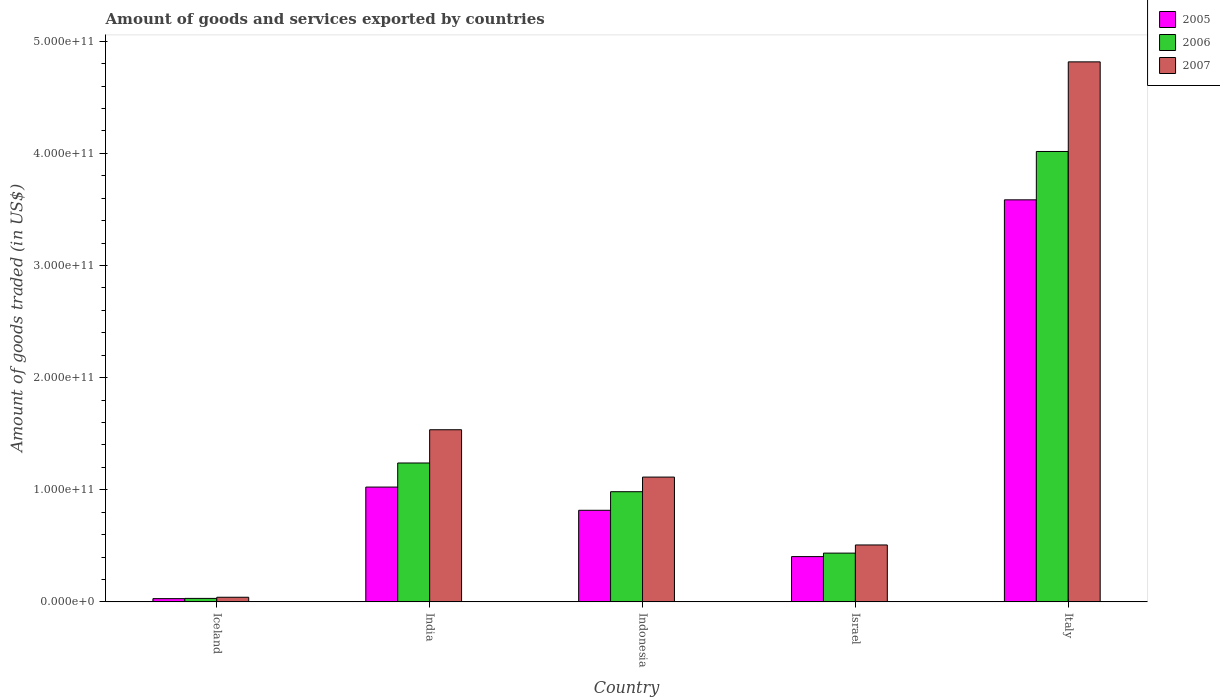How many different coloured bars are there?
Your answer should be very brief. 3. How many groups of bars are there?
Give a very brief answer. 5. Are the number of bars per tick equal to the number of legend labels?
Provide a succinct answer. Yes. Are the number of bars on each tick of the X-axis equal?
Make the answer very short. Yes. How many bars are there on the 3rd tick from the right?
Your answer should be compact. 3. What is the label of the 5th group of bars from the left?
Keep it short and to the point. Italy. In how many cases, is the number of bars for a given country not equal to the number of legend labels?
Keep it short and to the point. 0. What is the total amount of goods and services exported in 2007 in India?
Offer a very short reply. 1.54e+11. Across all countries, what is the maximum total amount of goods and services exported in 2005?
Provide a short and direct response. 3.59e+11. Across all countries, what is the minimum total amount of goods and services exported in 2006?
Make the answer very short. 3.10e+09. In which country was the total amount of goods and services exported in 2006 maximum?
Ensure brevity in your answer.  Italy. In which country was the total amount of goods and services exported in 2007 minimum?
Your answer should be compact. Iceland. What is the total total amount of goods and services exported in 2007 in the graph?
Offer a terse response. 8.01e+11. What is the difference between the total amount of goods and services exported in 2007 in India and that in Italy?
Ensure brevity in your answer.  -3.28e+11. What is the difference between the total amount of goods and services exported in 2006 in India and the total amount of goods and services exported in 2007 in Indonesia?
Offer a very short reply. 1.26e+1. What is the average total amount of goods and services exported in 2007 per country?
Your response must be concise. 1.60e+11. What is the difference between the total amount of goods and services exported of/in 2005 and total amount of goods and services exported of/in 2006 in Italy?
Provide a short and direct response. -4.31e+1. What is the ratio of the total amount of goods and services exported in 2006 in Iceland to that in Indonesia?
Provide a succinct answer. 0.03. Is the total amount of goods and services exported in 2005 in Iceland less than that in Israel?
Offer a terse response. Yes. What is the difference between the highest and the second highest total amount of goods and services exported in 2006?
Offer a very short reply. 2.78e+11. What is the difference between the highest and the lowest total amount of goods and services exported in 2006?
Give a very brief answer. 3.99e+11. In how many countries, is the total amount of goods and services exported in 2006 greater than the average total amount of goods and services exported in 2006 taken over all countries?
Make the answer very short. 1. Is the sum of the total amount of goods and services exported in 2005 in India and Israel greater than the maximum total amount of goods and services exported in 2007 across all countries?
Ensure brevity in your answer.  No. Is it the case that in every country, the sum of the total amount of goods and services exported in 2005 and total amount of goods and services exported in 2006 is greater than the total amount of goods and services exported in 2007?
Provide a succinct answer. Yes. How many bars are there?
Provide a short and direct response. 15. Are all the bars in the graph horizontal?
Provide a succinct answer. No. How many countries are there in the graph?
Ensure brevity in your answer.  5. What is the difference between two consecutive major ticks on the Y-axis?
Make the answer very short. 1.00e+11. Are the values on the major ticks of Y-axis written in scientific E-notation?
Offer a very short reply. Yes. How are the legend labels stacked?
Make the answer very short. Vertical. What is the title of the graph?
Provide a short and direct response. Amount of goods and services exported by countries. Does "2008" appear as one of the legend labels in the graph?
Ensure brevity in your answer.  No. What is the label or title of the Y-axis?
Give a very brief answer. Amount of goods traded (in US$). What is the Amount of goods traded (in US$) of 2005 in Iceland?
Your response must be concise. 2.89e+09. What is the Amount of goods traded (in US$) in 2006 in Iceland?
Your answer should be very brief. 3.10e+09. What is the Amount of goods traded (in US$) of 2007 in Iceland?
Ensure brevity in your answer.  4.12e+09. What is the Amount of goods traded (in US$) of 2005 in India?
Your answer should be very brief. 1.02e+11. What is the Amount of goods traded (in US$) in 2006 in India?
Give a very brief answer. 1.24e+11. What is the Amount of goods traded (in US$) in 2007 in India?
Make the answer very short. 1.54e+11. What is the Amount of goods traded (in US$) in 2005 in Indonesia?
Offer a very short reply. 8.17e+1. What is the Amount of goods traded (in US$) of 2006 in Indonesia?
Your response must be concise. 9.83e+1. What is the Amount of goods traded (in US$) in 2007 in Indonesia?
Offer a terse response. 1.11e+11. What is the Amount of goods traded (in US$) of 2005 in Israel?
Your response must be concise. 4.04e+1. What is the Amount of goods traded (in US$) of 2006 in Israel?
Offer a terse response. 4.35e+1. What is the Amount of goods traded (in US$) of 2007 in Israel?
Your response must be concise. 5.08e+1. What is the Amount of goods traded (in US$) of 2005 in Italy?
Provide a short and direct response. 3.59e+11. What is the Amount of goods traded (in US$) in 2006 in Italy?
Offer a terse response. 4.02e+11. What is the Amount of goods traded (in US$) of 2007 in Italy?
Ensure brevity in your answer.  4.82e+11. Across all countries, what is the maximum Amount of goods traded (in US$) of 2005?
Provide a succinct answer. 3.59e+11. Across all countries, what is the maximum Amount of goods traded (in US$) in 2006?
Make the answer very short. 4.02e+11. Across all countries, what is the maximum Amount of goods traded (in US$) in 2007?
Your answer should be compact. 4.82e+11. Across all countries, what is the minimum Amount of goods traded (in US$) of 2005?
Ensure brevity in your answer.  2.89e+09. Across all countries, what is the minimum Amount of goods traded (in US$) in 2006?
Your response must be concise. 3.10e+09. Across all countries, what is the minimum Amount of goods traded (in US$) of 2007?
Keep it short and to the point. 4.12e+09. What is the total Amount of goods traded (in US$) of 2005 in the graph?
Your answer should be compact. 5.86e+11. What is the total Amount of goods traded (in US$) in 2006 in the graph?
Keep it short and to the point. 6.70e+11. What is the total Amount of goods traded (in US$) in 2007 in the graph?
Give a very brief answer. 8.01e+11. What is the difference between the Amount of goods traded (in US$) in 2005 in Iceland and that in India?
Your answer should be very brief. -9.95e+1. What is the difference between the Amount of goods traded (in US$) in 2006 in Iceland and that in India?
Provide a succinct answer. -1.21e+11. What is the difference between the Amount of goods traded (in US$) in 2007 in Iceland and that in India?
Offer a terse response. -1.49e+11. What is the difference between the Amount of goods traded (in US$) in 2005 in Iceland and that in Indonesia?
Offer a terse response. -7.88e+1. What is the difference between the Amount of goods traded (in US$) in 2006 in Iceland and that in Indonesia?
Your response must be concise. -9.52e+1. What is the difference between the Amount of goods traded (in US$) in 2007 in Iceland and that in Indonesia?
Keep it short and to the point. -1.07e+11. What is the difference between the Amount of goods traded (in US$) in 2005 in Iceland and that in Israel?
Your answer should be compact. -3.75e+1. What is the difference between the Amount of goods traded (in US$) of 2006 in Iceland and that in Israel?
Provide a short and direct response. -4.04e+1. What is the difference between the Amount of goods traded (in US$) of 2007 in Iceland and that in Israel?
Your response must be concise. -4.66e+1. What is the difference between the Amount of goods traded (in US$) in 2005 in Iceland and that in Italy?
Your answer should be very brief. -3.56e+11. What is the difference between the Amount of goods traded (in US$) in 2006 in Iceland and that in Italy?
Ensure brevity in your answer.  -3.99e+11. What is the difference between the Amount of goods traded (in US$) of 2007 in Iceland and that in Italy?
Your answer should be very brief. -4.78e+11. What is the difference between the Amount of goods traded (in US$) of 2005 in India and that in Indonesia?
Give a very brief answer. 2.07e+1. What is the difference between the Amount of goods traded (in US$) in 2006 in India and that in Indonesia?
Offer a very short reply. 2.56e+1. What is the difference between the Amount of goods traded (in US$) of 2007 in India and that in Indonesia?
Your response must be concise. 4.22e+1. What is the difference between the Amount of goods traded (in US$) in 2005 in India and that in Israel?
Your answer should be very brief. 6.20e+1. What is the difference between the Amount of goods traded (in US$) of 2006 in India and that in Israel?
Give a very brief answer. 8.04e+1. What is the difference between the Amount of goods traded (in US$) in 2007 in India and that in Israel?
Your answer should be compact. 1.03e+11. What is the difference between the Amount of goods traded (in US$) of 2005 in India and that in Italy?
Offer a very short reply. -2.56e+11. What is the difference between the Amount of goods traded (in US$) of 2006 in India and that in Italy?
Keep it short and to the point. -2.78e+11. What is the difference between the Amount of goods traded (in US$) in 2007 in India and that in Italy?
Offer a terse response. -3.28e+11. What is the difference between the Amount of goods traded (in US$) in 2005 in Indonesia and that in Israel?
Your response must be concise. 4.13e+1. What is the difference between the Amount of goods traded (in US$) in 2006 in Indonesia and that in Israel?
Make the answer very short. 5.48e+1. What is the difference between the Amount of goods traded (in US$) in 2007 in Indonesia and that in Israel?
Make the answer very short. 6.05e+1. What is the difference between the Amount of goods traded (in US$) of 2005 in Indonesia and that in Italy?
Ensure brevity in your answer.  -2.77e+11. What is the difference between the Amount of goods traded (in US$) of 2006 in Indonesia and that in Italy?
Offer a terse response. -3.03e+11. What is the difference between the Amount of goods traded (in US$) of 2007 in Indonesia and that in Italy?
Keep it short and to the point. -3.70e+11. What is the difference between the Amount of goods traded (in US$) in 2005 in Israel and that in Italy?
Your answer should be very brief. -3.18e+11. What is the difference between the Amount of goods traded (in US$) in 2006 in Israel and that in Italy?
Offer a terse response. -3.58e+11. What is the difference between the Amount of goods traded (in US$) in 2007 in Israel and that in Italy?
Give a very brief answer. -4.31e+11. What is the difference between the Amount of goods traded (in US$) of 2005 in Iceland and the Amount of goods traded (in US$) of 2006 in India?
Offer a terse response. -1.21e+11. What is the difference between the Amount of goods traded (in US$) in 2005 in Iceland and the Amount of goods traded (in US$) in 2007 in India?
Provide a short and direct response. -1.51e+11. What is the difference between the Amount of goods traded (in US$) in 2006 in Iceland and the Amount of goods traded (in US$) in 2007 in India?
Give a very brief answer. -1.50e+11. What is the difference between the Amount of goods traded (in US$) in 2005 in Iceland and the Amount of goods traded (in US$) in 2006 in Indonesia?
Provide a short and direct response. -9.54e+1. What is the difference between the Amount of goods traded (in US$) in 2005 in Iceland and the Amount of goods traded (in US$) in 2007 in Indonesia?
Your answer should be very brief. -1.08e+11. What is the difference between the Amount of goods traded (in US$) in 2006 in Iceland and the Amount of goods traded (in US$) in 2007 in Indonesia?
Offer a terse response. -1.08e+11. What is the difference between the Amount of goods traded (in US$) of 2005 in Iceland and the Amount of goods traded (in US$) of 2006 in Israel?
Your answer should be very brief. -4.06e+1. What is the difference between the Amount of goods traded (in US$) in 2005 in Iceland and the Amount of goods traded (in US$) in 2007 in Israel?
Provide a short and direct response. -4.79e+1. What is the difference between the Amount of goods traded (in US$) of 2006 in Iceland and the Amount of goods traded (in US$) of 2007 in Israel?
Provide a short and direct response. -4.77e+1. What is the difference between the Amount of goods traded (in US$) of 2005 in Iceland and the Amount of goods traded (in US$) of 2006 in Italy?
Offer a terse response. -3.99e+11. What is the difference between the Amount of goods traded (in US$) of 2005 in Iceland and the Amount of goods traded (in US$) of 2007 in Italy?
Your answer should be very brief. -4.79e+11. What is the difference between the Amount of goods traded (in US$) in 2006 in Iceland and the Amount of goods traded (in US$) in 2007 in Italy?
Ensure brevity in your answer.  -4.79e+11. What is the difference between the Amount of goods traded (in US$) of 2005 in India and the Amount of goods traded (in US$) of 2006 in Indonesia?
Your response must be concise. 4.15e+09. What is the difference between the Amount of goods traded (in US$) in 2005 in India and the Amount of goods traded (in US$) in 2007 in Indonesia?
Your response must be concise. -8.90e+09. What is the difference between the Amount of goods traded (in US$) of 2006 in India and the Amount of goods traded (in US$) of 2007 in Indonesia?
Your answer should be very brief. 1.26e+1. What is the difference between the Amount of goods traded (in US$) in 2005 in India and the Amount of goods traded (in US$) in 2006 in Israel?
Ensure brevity in your answer.  5.89e+1. What is the difference between the Amount of goods traded (in US$) in 2005 in India and the Amount of goods traded (in US$) in 2007 in Israel?
Offer a very short reply. 5.16e+1. What is the difference between the Amount of goods traded (in US$) of 2006 in India and the Amount of goods traded (in US$) of 2007 in Israel?
Offer a very short reply. 7.31e+1. What is the difference between the Amount of goods traded (in US$) of 2005 in India and the Amount of goods traded (in US$) of 2006 in Italy?
Keep it short and to the point. -2.99e+11. What is the difference between the Amount of goods traded (in US$) of 2005 in India and the Amount of goods traded (in US$) of 2007 in Italy?
Offer a terse response. -3.79e+11. What is the difference between the Amount of goods traded (in US$) of 2006 in India and the Amount of goods traded (in US$) of 2007 in Italy?
Ensure brevity in your answer.  -3.58e+11. What is the difference between the Amount of goods traded (in US$) of 2005 in Indonesia and the Amount of goods traded (in US$) of 2006 in Israel?
Your answer should be compact. 3.82e+1. What is the difference between the Amount of goods traded (in US$) in 2005 in Indonesia and the Amount of goods traded (in US$) in 2007 in Israel?
Make the answer very short. 3.09e+1. What is the difference between the Amount of goods traded (in US$) in 2006 in Indonesia and the Amount of goods traded (in US$) in 2007 in Israel?
Provide a succinct answer. 4.75e+1. What is the difference between the Amount of goods traded (in US$) in 2005 in Indonesia and the Amount of goods traded (in US$) in 2006 in Italy?
Your response must be concise. -3.20e+11. What is the difference between the Amount of goods traded (in US$) in 2005 in Indonesia and the Amount of goods traded (in US$) in 2007 in Italy?
Provide a short and direct response. -4.00e+11. What is the difference between the Amount of goods traded (in US$) of 2006 in Indonesia and the Amount of goods traded (in US$) of 2007 in Italy?
Make the answer very short. -3.83e+11. What is the difference between the Amount of goods traded (in US$) of 2005 in Israel and the Amount of goods traded (in US$) of 2006 in Italy?
Ensure brevity in your answer.  -3.61e+11. What is the difference between the Amount of goods traded (in US$) in 2005 in Israel and the Amount of goods traded (in US$) in 2007 in Italy?
Your answer should be very brief. -4.41e+11. What is the difference between the Amount of goods traded (in US$) of 2006 in Israel and the Amount of goods traded (in US$) of 2007 in Italy?
Your answer should be compact. -4.38e+11. What is the average Amount of goods traded (in US$) of 2005 per country?
Your answer should be very brief. 1.17e+11. What is the average Amount of goods traded (in US$) of 2006 per country?
Offer a very short reply. 1.34e+11. What is the average Amount of goods traded (in US$) of 2007 per country?
Offer a very short reply. 1.60e+11. What is the difference between the Amount of goods traded (in US$) of 2005 and Amount of goods traded (in US$) of 2006 in Iceland?
Provide a succinct answer. -2.13e+08. What is the difference between the Amount of goods traded (in US$) in 2005 and Amount of goods traded (in US$) in 2007 in Iceland?
Ensure brevity in your answer.  -1.23e+09. What is the difference between the Amount of goods traded (in US$) in 2006 and Amount of goods traded (in US$) in 2007 in Iceland?
Provide a succinct answer. -1.02e+09. What is the difference between the Amount of goods traded (in US$) in 2005 and Amount of goods traded (in US$) in 2006 in India?
Keep it short and to the point. -2.15e+1. What is the difference between the Amount of goods traded (in US$) of 2005 and Amount of goods traded (in US$) of 2007 in India?
Your response must be concise. -5.11e+1. What is the difference between the Amount of goods traded (in US$) in 2006 and Amount of goods traded (in US$) in 2007 in India?
Your answer should be very brief. -2.97e+1. What is the difference between the Amount of goods traded (in US$) of 2005 and Amount of goods traded (in US$) of 2006 in Indonesia?
Offer a very short reply. -1.66e+1. What is the difference between the Amount of goods traded (in US$) of 2005 and Amount of goods traded (in US$) of 2007 in Indonesia?
Provide a short and direct response. -2.96e+1. What is the difference between the Amount of goods traded (in US$) of 2006 and Amount of goods traded (in US$) of 2007 in Indonesia?
Give a very brief answer. -1.31e+1. What is the difference between the Amount of goods traded (in US$) of 2005 and Amount of goods traded (in US$) of 2006 in Israel?
Provide a succinct answer. -3.12e+09. What is the difference between the Amount of goods traded (in US$) of 2005 and Amount of goods traded (in US$) of 2007 in Israel?
Offer a very short reply. -1.04e+1. What is the difference between the Amount of goods traded (in US$) in 2006 and Amount of goods traded (in US$) in 2007 in Israel?
Make the answer very short. -7.27e+09. What is the difference between the Amount of goods traded (in US$) of 2005 and Amount of goods traded (in US$) of 2006 in Italy?
Make the answer very short. -4.31e+1. What is the difference between the Amount of goods traded (in US$) in 2005 and Amount of goods traded (in US$) in 2007 in Italy?
Your answer should be compact. -1.23e+11. What is the difference between the Amount of goods traded (in US$) of 2006 and Amount of goods traded (in US$) of 2007 in Italy?
Give a very brief answer. -7.99e+1. What is the ratio of the Amount of goods traded (in US$) of 2005 in Iceland to that in India?
Provide a succinct answer. 0.03. What is the ratio of the Amount of goods traded (in US$) of 2006 in Iceland to that in India?
Offer a very short reply. 0.03. What is the ratio of the Amount of goods traded (in US$) in 2007 in Iceland to that in India?
Make the answer very short. 0.03. What is the ratio of the Amount of goods traded (in US$) of 2005 in Iceland to that in Indonesia?
Offer a terse response. 0.04. What is the ratio of the Amount of goods traded (in US$) in 2006 in Iceland to that in Indonesia?
Your answer should be compact. 0.03. What is the ratio of the Amount of goods traded (in US$) of 2007 in Iceland to that in Indonesia?
Provide a short and direct response. 0.04. What is the ratio of the Amount of goods traded (in US$) of 2005 in Iceland to that in Israel?
Provide a short and direct response. 0.07. What is the ratio of the Amount of goods traded (in US$) of 2006 in Iceland to that in Israel?
Provide a short and direct response. 0.07. What is the ratio of the Amount of goods traded (in US$) of 2007 in Iceland to that in Israel?
Offer a terse response. 0.08. What is the ratio of the Amount of goods traded (in US$) in 2005 in Iceland to that in Italy?
Give a very brief answer. 0.01. What is the ratio of the Amount of goods traded (in US$) of 2006 in Iceland to that in Italy?
Your response must be concise. 0.01. What is the ratio of the Amount of goods traded (in US$) of 2007 in Iceland to that in Italy?
Offer a terse response. 0.01. What is the ratio of the Amount of goods traded (in US$) in 2005 in India to that in Indonesia?
Make the answer very short. 1.25. What is the ratio of the Amount of goods traded (in US$) of 2006 in India to that in Indonesia?
Your answer should be compact. 1.26. What is the ratio of the Amount of goods traded (in US$) of 2007 in India to that in Indonesia?
Offer a terse response. 1.38. What is the ratio of the Amount of goods traded (in US$) in 2005 in India to that in Israel?
Offer a very short reply. 2.54. What is the ratio of the Amount of goods traded (in US$) of 2006 in India to that in Israel?
Give a very brief answer. 2.85. What is the ratio of the Amount of goods traded (in US$) of 2007 in India to that in Israel?
Your answer should be very brief. 3.02. What is the ratio of the Amount of goods traded (in US$) in 2005 in India to that in Italy?
Give a very brief answer. 0.29. What is the ratio of the Amount of goods traded (in US$) of 2006 in India to that in Italy?
Provide a short and direct response. 0.31. What is the ratio of the Amount of goods traded (in US$) in 2007 in India to that in Italy?
Give a very brief answer. 0.32. What is the ratio of the Amount of goods traded (in US$) in 2005 in Indonesia to that in Israel?
Provide a short and direct response. 2.02. What is the ratio of the Amount of goods traded (in US$) in 2006 in Indonesia to that in Israel?
Give a very brief answer. 2.26. What is the ratio of the Amount of goods traded (in US$) of 2007 in Indonesia to that in Israel?
Offer a terse response. 2.19. What is the ratio of the Amount of goods traded (in US$) of 2005 in Indonesia to that in Italy?
Offer a very short reply. 0.23. What is the ratio of the Amount of goods traded (in US$) in 2006 in Indonesia to that in Italy?
Offer a very short reply. 0.24. What is the ratio of the Amount of goods traded (in US$) in 2007 in Indonesia to that in Italy?
Keep it short and to the point. 0.23. What is the ratio of the Amount of goods traded (in US$) of 2005 in Israel to that in Italy?
Make the answer very short. 0.11. What is the ratio of the Amount of goods traded (in US$) of 2006 in Israel to that in Italy?
Your response must be concise. 0.11. What is the ratio of the Amount of goods traded (in US$) in 2007 in Israel to that in Italy?
Your answer should be very brief. 0.11. What is the difference between the highest and the second highest Amount of goods traded (in US$) in 2005?
Your answer should be very brief. 2.56e+11. What is the difference between the highest and the second highest Amount of goods traded (in US$) in 2006?
Keep it short and to the point. 2.78e+11. What is the difference between the highest and the second highest Amount of goods traded (in US$) in 2007?
Make the answer very short. 3.28e+11. What is the difference between the highest and the lowest Amount of goods traded (in US$) in 2005?
Your response must be concise. 3.56e+11. What is the difference between the highest and the lowest Amount of goods traded (in US$) of 2006?
Keep it short and to the point. 3.99e+11. What is the difference between the highest and the lowest Amount of goods traded (in US$) of 2007?
Offer a very short reply. 4.78e+11. 